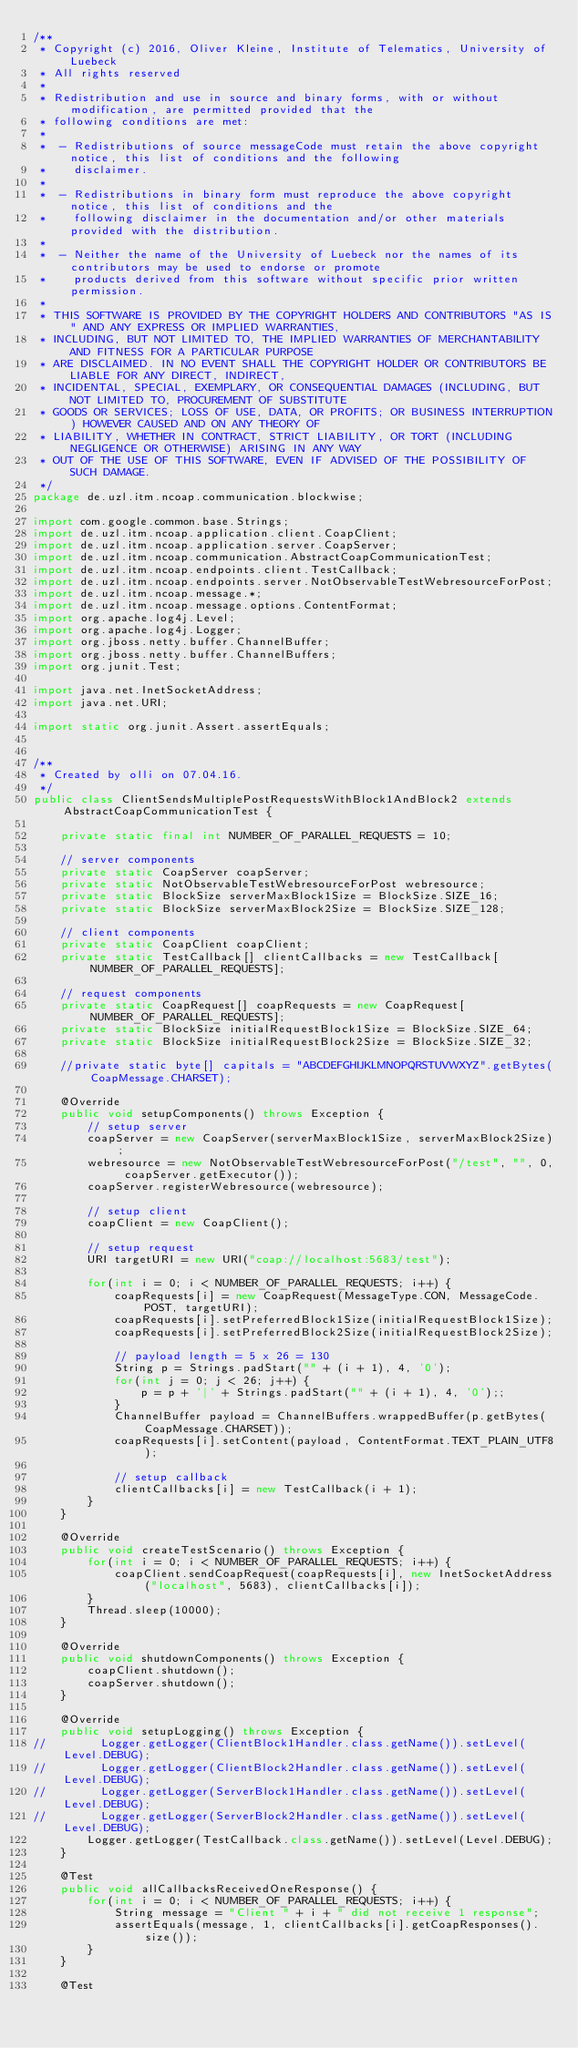<code> <loc_0><loc_0><loc_500><loc_500><_Java_>/**
 * Copyright (c) 2016, Oliver Kleine, Institute of Telematics, University of Luebeck
 * All rights reserved
 *
 * Redistribution and use in source and binary forms, with or without modification, are permitted provided that the
 * following conditions are met:
 *
 *  - Redistributions of source messageCode must retain the above copyright notice, this list of conditions and the following
 *    disclaimer.
 *
 *  - Redistributions in binary form must reproduce the above copyright notice, this list of conditions and the
 *    following disclaimer in the documentation and/or other materials provided with the distribution.
 *
 *  - Neither the name of the University of Luebeck nor the names of its contributors may be used to endorse or promote
 *    products derived from this software without specific prior written permission.
 *
 * THIS SOFTWARE IS PROVIDED BY THE COPYRIGHT HOLDERS AND CONTRIBUTORS "AS IS" AND ANY EXPRESS OR IMPLIED WARRANTIES,
 * INCLUDING, BUT NOT LIMITED TO, THE IMPLIED WARRANTIES OF MERCHANTABILITY AND FITNESS FOR A PARTICULAR PURPOSE
 * ARE DISCLAIMED. IN NO EVENT SHALL THE COPYRIGHT HOLDER OR CONTRIBUTORS BE LIABLE FOR ANY DIRECT, INDIRECT,
 * INCIDENTAL, SPECIAL, EXEMPLARY, OR CONSEQUENTIAL DAMAGES (INCLUDING, BUT NOT LIMITED TO, PROCUREMENT OF SUBSTITUTE
 * GOODS OR SERVICES; LOSS OF USE, DATA, OR PROFITS; OR BUSINESS INTERRUPTION) HOWEVER CAUSED AND ON ANY THEORY OF
 * LIABILITY, WHETHER IN CONTRACT, STRICT LIABILITY, OR TORT (INCLUDING NEGLIGENCE OR OTHERWISE) ARISING IN ANY WAY
 * OUT OF THE USE OF THIS SOFTWARE, EVEN IF ADVISED OF THE POSSIBILITY OF SUCH DAMAGE.
 */
package de.uzl.itm.ncoap.communication.blockwise;

import com.google.common.base.Strings;
import de.uzl.itm.ncoap.application.client.CoapClient;
import de.uzl.itm.ncoap.application.server.CoapServer;
import de.uzl.itm.ncoap.communication.AbstractCoapCommunicationTest;
import de.uzl.itm.ncoap.endpoints.client.TestCallback;
import de.uzl.itm.ncoap.endpoints.server.NotObservableTestWebresourceForPost;
import de.uzl.itm.ncoap.message.*;
import de.uzl.itm.ncoap.message.options.ContentFormat;
import org.apache.log4j.Level;
import org.apache.log4j.Logger;
import org.jboss.netty.buffer.ChannelBuffer;
import org.jboss.netty.buffer.ChannelBuffers;
import org.junit.Test;

import java.net.InetSocketAddress;
import java.net.URI;

import static org.junit.Assert.assertEquals;


/**
 * Created by olli on 07.04.16.
 */
public class ClientSendsMultiplePostRequestsWithBlock1AndBlock2 extends AbstractCoapCommunicationTest {

    private static final int NUMBER_OF_PARALLEL_REQUESTS = 10;

    // server components
    private static CoapServer coapServer;
    private static NotObservableTestWebresourceForPost webresource;
    private static BlockSize serverMaxBlock1Size = BlockSize.SIZE_16;
    private static BlockSize serverMaxBlock2Size = BlockSize.SIZE_128;

    // client components
    private static CoapClient coapClient;
    private static TestCallback[] clientCallbacks = new TestCallback[NUMBER_OF_PARALLEL_REQUESTS];

    // request components
    private static CoapRequest[] coapRequests = new CoapRequest[NUMBER_OF_PARALLEL_REQUESTS];
    private static BlockSize initialRequestBlock1Size = BlockSize.SIZE_64;
    private static BlockSize initialRequestBlock2Size = BlockSize.SIZE_32;

    //private static byte[] capitals = "ABCDEFGHIJKLMNOPQRSTUVWXYZ".getBytes(CoapMessage.CHARSET);

    @Override
    public void setupComponents() throws Exception {
        // setup server
        coapServer = new CoapServer(serverMaxBlock1Size, serverMaxBlock2Size);
        webresource = new NotObservableTestWebresourceForPost("/test", "", 0, coapServer.getExecutor());
        coapServer.registerWebresource(webresource);

        // setup client
        coapClient = new CoapClient();

        // setup request
        URI targetURI = new URI("coap://localhost:5683/test");

        for(int i = 0; i < NUMBER_OF_PARALLEL_REQUESTS; i++) {
            coapRequests[i] = new CoapRequest(MessageType.CON, MessageCode.POST, targetURI);
            coapRequests[i].setPreferredBlock1Size(initialRequestBlock1Size);
            coapRequests[i].setPreferredBlock2Size(initialRequestBlock2Size);

            // payload length = 5 x 26 = 130
            String p = Strings.padStart("" + (i + 1), 4, '0');
            for(int j = 0; j < 26; j++) {
                p = p + '|' + Strings.padStart("" + (i + 1), 4, '0');;
            }
            ChannelBuffer payload = ChannelBuffers.wrappedBuffer(p.getBytes(CoapMessage.CHARSET));
            coapRequests[i].setContent(payload, ContentFormat.TEXT_PLAIN_UTF8);

            // setup callback
            clientCallbacks[i] = new TestCallback(i + 1);
        }
    }

    @Override
    public void createTestScenario() throws Exception {
        for(int i = 0; i < NUMBER_OF_PARALLEL_REQUESTS; i++) {
            coapClient.sendCoapRequest(coapRequests[i], new InetSocketAddress("localhost", 5683), clientCallbacks[i]);
        }
        Thread.sleep(10000);
    }

    @Override
    public void shutdownComponents() throws Exception {
        coapClient.shutdown();
        coapServer.shutdown();
    }

    @Override
    public void setupLogging() throws Exception {
//        Logger.getLogger(ClientBlock1Handler.class.getName()).setLevel(Level.DEBUG);
//        Logger.getLogger(ClientBlock2Handler.class.getName()).setLevel(Level.DEBUG);
//        Logger.getLogger(ServerBlock1Handler.class.getName()).setLevel(Level.DEBUG);
//        Logger.getLogger(ServerBlock2Handler.class.getName()).setLevel(Level.DEBUG);
        Logger.getLogger(TestCallback.class.getName()).setLevel(Level.DEBUG);
    }

    @Test
    public void allCallbacksReceivedOneResponse() {
        for(int i = 0; i < NUMBER_OF_PARALLEL_REQUESTS; i++) {
            String message = "Client " + i + " did not receive 1 response";
            assertEquals(message, 1, clientCallbacks[i].getCoapResponses().size());
        }
    }

    @Test</code> 